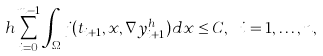<formula> <loc_0><loc_0><loc_500><loc_500>h \sum _ { i = 0 } ^ { m - 1 } \int _ { \Omega } j ( t _ { i + 1 } , x , \nabla y _ { i + 1 } ^ { h } ) d x \leq C , \ i = 1 , \dots , n ,</formula> 